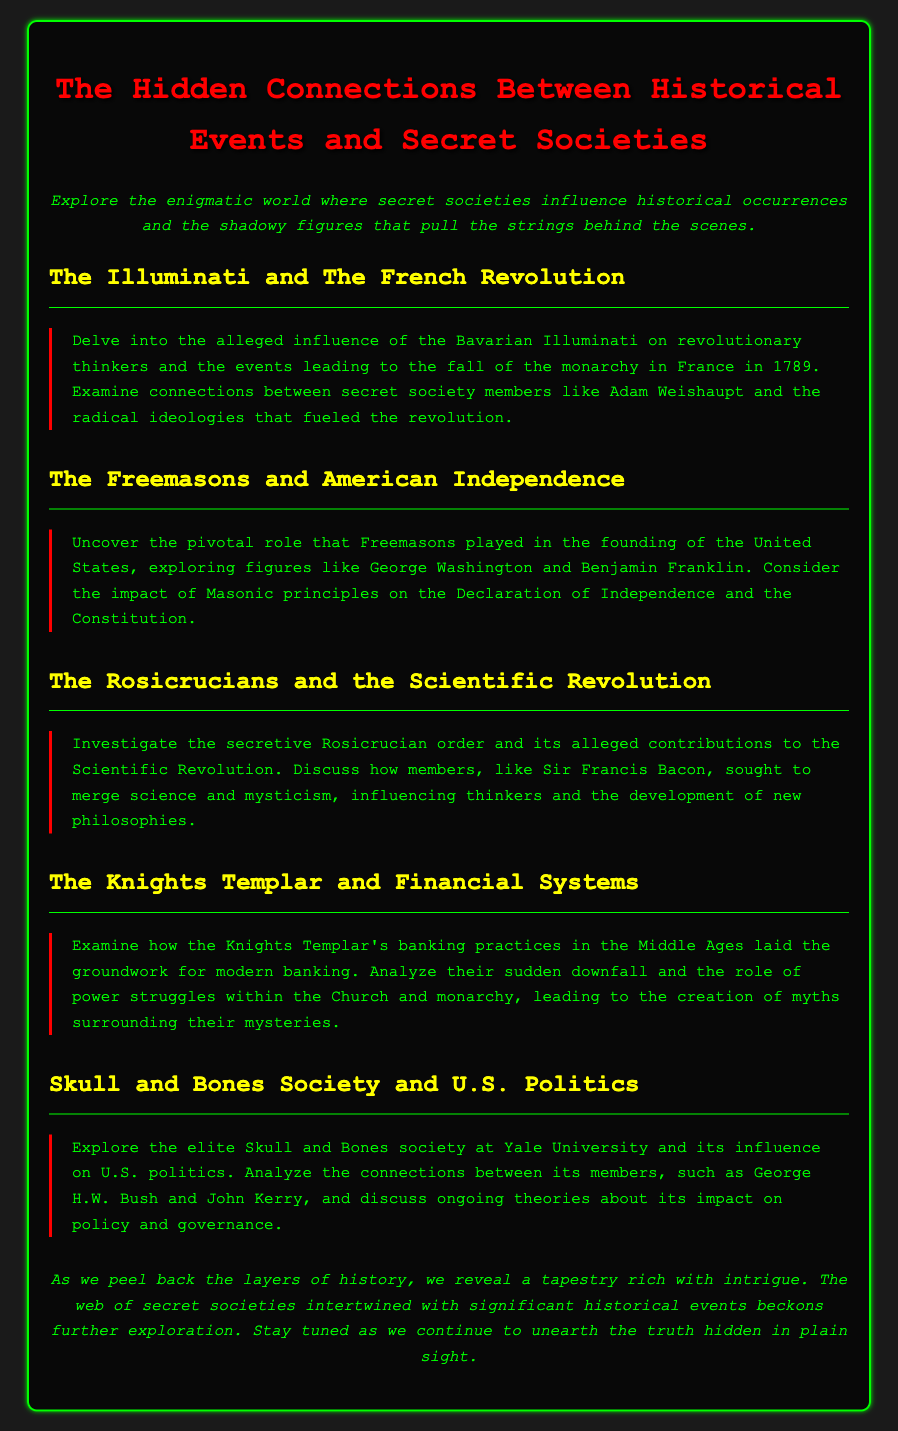What secret society is linked to the French Revolution? The document states that the Bavarian Illuminati is alleged to influence revolutionary thinkers during the French Revolution.
Answer: Bavarian Illuminati Who were key figures associated with the Freemasons in the U.S. founding? The document mentions George Washington and Benjamin Franklin as pivotal Freemasons involved in the founding of the United States.
Answer: George Washington and Benjamin Franklin What order is connected to the Scientific Revolution? The document highlights the Rosicrucian order as having alleged contributions to the Scientific Revolution.
Answer: Rosicrucian order What was a significant practice of the Knights Templar? The document refers to the banking practices of the Knights Templar in the Middle Ages as laying groundwork for modern banking.
Answer: Banking practices Which elite society is mentioned in relation to U.S. politics? The document discusses the Skull and Bones society and its influence on U.S. politics.
Answer: Skull and Bones society What year did the French Revolution begin? The document states the fall of the monarchy in France occurred in 1789 during the French Revolution.
Answer: 1789 Who was involved in discussions about the impact of Masonic principles? The document cites figures like George Washington and Benjamin Franklin regarding the impact of Masonic principles on U.S. foundational documents.
Answer: George Washington and Benjamin Franklin How did the Rosicrucians influence thought? The document notes that members like Sir Francis Bacon sought to merge science and mysticism, influencing new philosophies.
Answer: Merging science and mysticism What does the conclusion suggest about the nature of history? The conclusion implies that history is layered with intrigue and involves a web of secret societies.
Answer: A tapestry rich with intrigue 